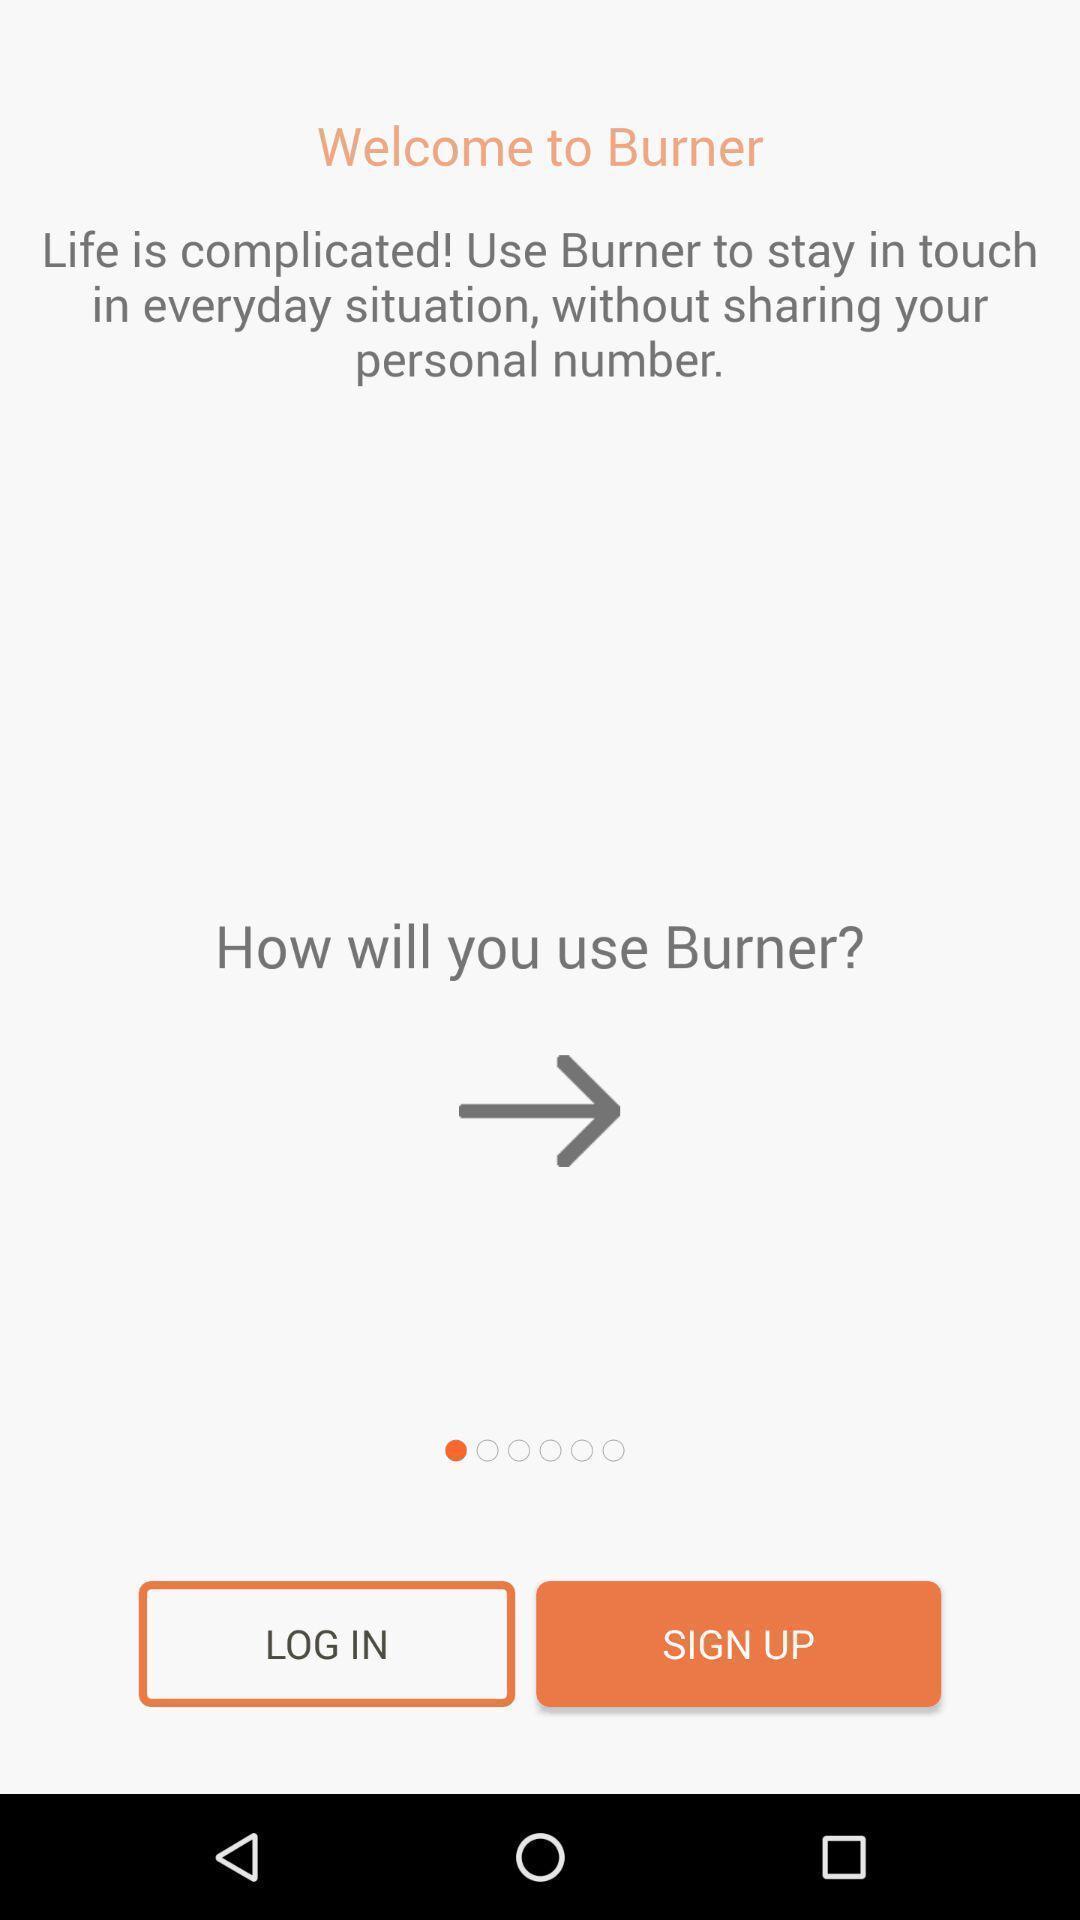What can you discern from this picture? Welcome page for login to an social application. 